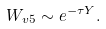<formula> <loc_0><loc_0><loc_500><loc_500>W _ { v 5 } \sim e ^ { - \tau { Y } } .</formula> 